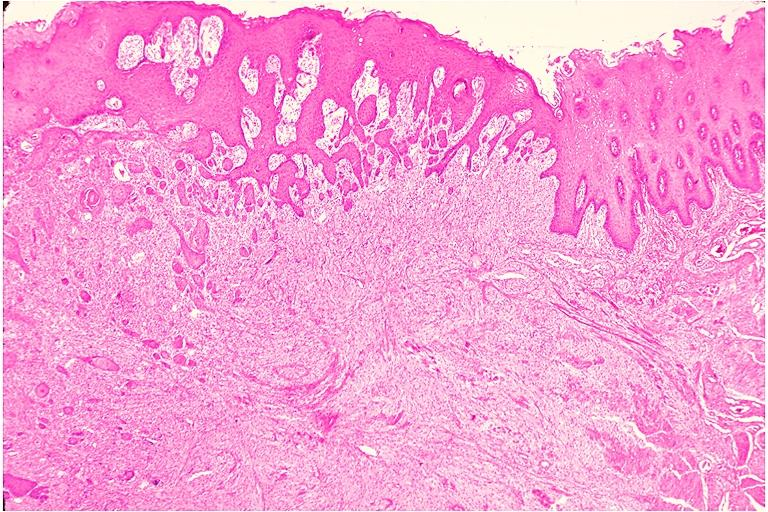s oral present?
Answer the question using a single word or phrase. Yes 